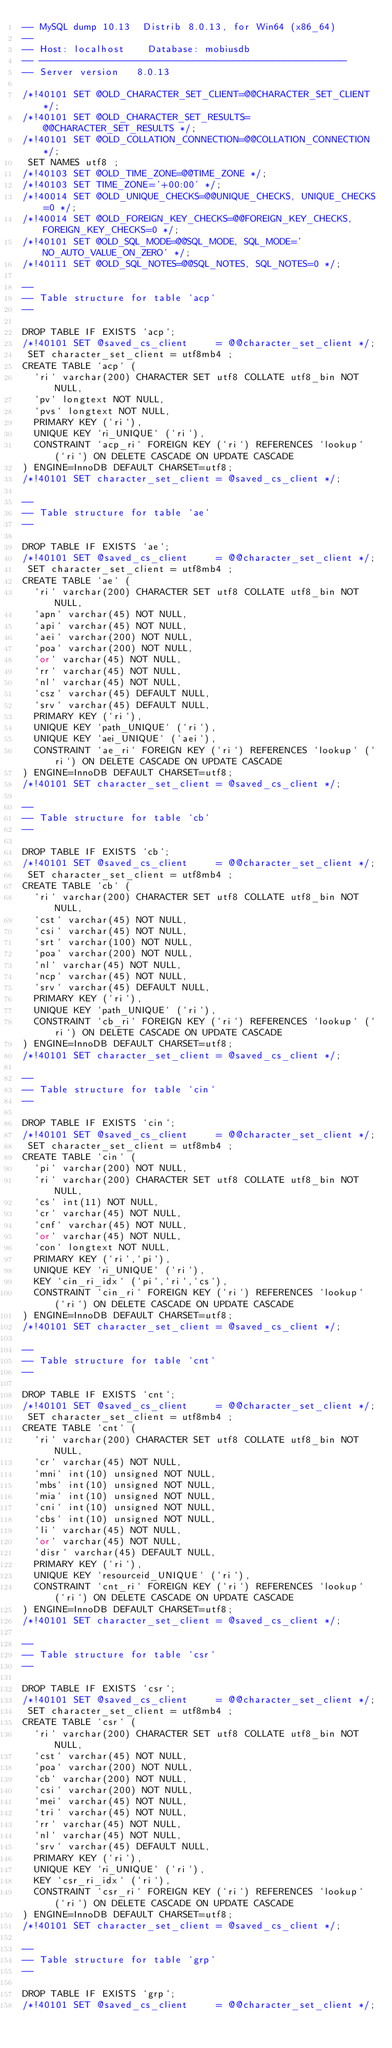<code> <loc_0><loc_0><loc_500><loc_500><_SQL_>-- MySQL dump 10.13  Distrib 8.0.13, for Win64 (x86_64)
--
-- Host: localhost    Database: mobiusdb
-- ------------------------------------------------------
-- Server version	8.0.13

/*!40101 SET @OLD_CHARACTER_SET_CLIENT=@@CHARACTER_SET_CLIENT */;
/*!40101 SET @OLD_CHARACTER_SET_RESULTS=@@CHARACTER_SET_RESULTS */;
/*!40101 SET @OLD_COLLATION_CONNECTION=@@COLLATION_CONNECTION */;
 SET NAMES utf8 ;
/*!40103 SET @OLD_TIME_ZONE=@@TIME_ZONE */;
/*!40103 SET TIME_ZONE='+00:00' */;
/*!40014 SET @OLD_UNIQUE_CHECKS=@@UNIQUE_CHECKS, UNIQUE_CHECKS=0 */;
/*!40014 SET @OLD_FOREIGN_KEY_CHECKS=@@FOREIGN_KEY_CHECKS, FOREIGN_KEY_CHECKS=0 */;
/*!40101 SET @OLD_SQL_MODE=@@SQL_MODE, SQL_MODE='NO_AUTO_VALUE_ON_ZERO' */;
/*!40111 SET @OLD_SQL_NOTES=@@SQL_NOTES, SQL_NOTES=0 */;

--
-- Table structure for table `acp`
--

DROP TABLE IF EXISTS `acp`;
/*!40101 SET @saved_cs_client     = @@character_set_client */;
 SET character_set_client = utf8mb4 ;
CREATE TABLE `acp` (
  `ri` varchar(200) CHARACTER SET utf8 COLLATE utf8_bin NOT NULL,
  `pv` longtext NOT NULL,
  `pvs` longtext NOT NULL,
  PRIMARY KEY (`ri`),
  UNIQUE KEY `ri_UNIQUE` (`ri`),
  CONSTRAINT `acp_ri` FOREIGN KEY (`ri`) REFERENCES `lookup` (`ri`) ON DELETE CASCADE ON UPDATE CASCADE
) ENGINE=InnoDB DEFAULT CHARSET=utf8;
/*!40101 SET character_set_client = @saved_cs_client */;

--
-- Table structure for table `ae`
--

DROP TABLE IF EXISTS `ae`;
/*!40101 SET @saved_cs_client     = @@character_set_client */;
 SET character_set_client = utf8mb4 ;
CREATE TABLE `ae` (
  `ri` varchar(200) CHARACTER SET utf8 COLLATE utf8_bin NOT NULL,
  `apn` varchar(45) NOT NULL,
  `api` varchar(45) NOT NULL,
  `aei` varchar(200) NOT NULL,
  `poa` varchar(200) NOT NULL,
  `or` varchar(45) NOT NULL,
  `rr` varchar(45) NOT NULL,
  `nl` varchar(45) NOT NULL,
  `csz` varchar(45) DEFAULT NULL,
  `srv` varchar(45) DEFAULT NULL,
  PRIMARY KEY (`ri`),
  UNIQUE KEY `path_UNIQUE` (`ri`),
  UNIQUE KEY `aei_UNIQUE` (`aei`),
  CONSTRAINT `ae_ri` FOREIGN KEY (`ri`) REFERENCES `lookup` (`ri`) ON DELETE CASCADE ON UPDATE CASCADE
) ENGINE=InnoDB DEFAULT CHARSET=utf8;
/*!40101 SET character_set_client = @saved_cs_client */;

--
-- Table structure for table `cb`
--

DROP TABLE IF EXISTS `cb`;
/*!40101 SET @saved_cs_client     = @@character_set_client */;
 SET character_set_client = utf8mb4 ;
CREATE TABLE `cb` (
  `ri` varchar(200) CHARACTER SET utf8 COLLATE utf8_bin NOT NULL,
  `cst` varchar(45) NOT NULL,
  `csi` varchar(45) NOT NULL,
  `srt` varchar(100) NOT NULL,
  `poa` varchar(200) NOT NULL,
  `nl` varchar(45) NOT NULL,
  `ncp` varchar(45) NOT NULL,
  `srv` varchar(45) DEFAULT NULL,
  PRIMARY KEY (`ri`),
  UNIQUE KEY `path_UNIQUE` (`ri`),
  CONSTRAINT `cb_ri` FOREIGN KEY (`ri`) REFERENCES `lookup` (`ri`) ON DELETE CASCADE ON UPDATE CASCADE
) ENGINE=InnoDB DEFAULT CHARSET=utf8;
/*!40101 SET character_set_client = @saved_cs_client */;

--
-- Table structure for table `cin`
--

DROP TABLE IF EXISTS `cin`;
/*!40101 SET @saved_cs_client     = @@character_set_client */;
 SET character_set_client = utf8mb4 ;
CREATE TABLE `cin` (
  `pi` varchar(200) NOT NULL,
  `ri` varchar(200) CHARACTER SET utf8 COLLATE utf8_bin NOT NULL,
  `cs` int(11) NOT NULL,
  `cr` varchar(45) NOT NULL,
  `cnf` varchar(45) NOT NULL,
  `or` varchar(45) NOT NULL,
  `con` longtext NOT NULL,
  PRIMARY KEY (`ri`,`pi`),
  UNIQUE KEY `ri_UNIQUE` (`ri`),
  KEY `cin_ri_idx` (`pi`,`ri`,`cs`),
  CONSTRAINT `cin_ri` FOREIGN KEY (`ri`) REFERENCES `lookup` (`ri`) ON DELETE CASCADE ON UPDATE CASCADE
) ENGINE=InnoDB DEFAULT CHARSET=utf8;
/*!40101 SET character_set_client = @saved_cs_client */;

--
-- Table structure for table `cnt`
--

DROP TABLE IF EXISTS `cnt`;
/*!40101 SET @saved_cs_client     = @@character_set_client */;
 SET character_set_client = utf8mb4 ;
CREATE TABLE `cnt` (
  `ri` varchar(200) CHARACTER SET utf8 COLLATE utf8_bin NOT NULL,
  `cr` varchar(45) NOT NULL,
  `mni` int(10) unsigned NOT NULL,
  `mbs` int(10) unsigned NOT NULL,
  `mia` int(10) unsigned NOT NULL,
  `cni` int(10) unsigned NOT NULL,
  `cbs` int(10) unsigned NOT NULL,
  `li` varchar(45) NOT NULL,
  `or` varchar(45) NOT NULL,
  `disr` varchar(45) DEFAULT NULL,
  PRIMARY KEY (`ri`),
  UNIQUE KEY `resourceid_UNIQUE` (`ri`),
  CONSTRAINT `cnt_ri` FOREIGN KEY (`ri`) REFERENCES `lookup` (`ri`) ON DELETE CASCADE ON UPDATE CASCADE
) ENGINE=InnoDB DEFAULT CHARSET=utf8;
/*!40101 SET character_set_client = @saved_cs_client */;

--
-- Table structure for table `csr`
--

DROP TABLE IF EXISTS `csr`;
/*!40101 SET @saved_cs_client     = @@character_set_client */;
 SET character_set_client = utf8mb4 ;
CREATE TABLE `csr` (
  `ri` varchar(200) CHARACTER SET utf8 COLLATE utf8_bin NOT NULL,
  `cst` varchar(45) NOT NULL,
  `poa` varchar(200) NOT NULL,
  `cb` varchar(200) NOT NULL,
  `csi` varchar(200) NOT NULL,
  `mei` varchar(45) NOT NULL,
  `tri` varchar(45) NOT NULL,
  `rr` varchar(45) NOT NULL,
  `nl` varchar(45) NOT NULL,
  `srv` varchar(45) DEFAULT NULL,
  PRIMARY KEY (`ri`),
  UNIQUE KEY `ri_UNIQUE` (`ri`),
  KEY `csr_ri_idx` (`ri`),
  CONSTRAINT `csr_ri` FOREIGN KEY (`ri`) REFERENCES `lookup` (`ri`) ON DELETE CASCADE ON UPDATE CASCADE
) ENGINE=InnoDB DEFAULT CHARSET=utf8;
/*!40101 SET character_set_client = @saved_cs_client */;

--
-- Table structure for table `grp`
--

DROP TABLE IF EXISTS `grp`;
/*!40101 SET @saved_cs_client     = @@character_set_client */;</code> 